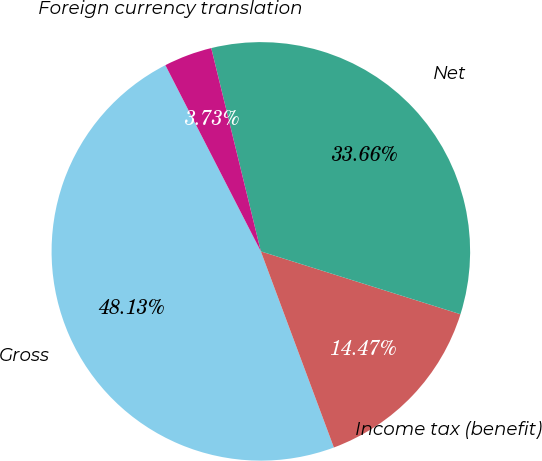Convert chart to OTSL. <chart><loc_0><loc_0><loc_500><loc_500><pie_chart><fcel>Gross<fcel>Income tax (benefit)<fcel>Net<fcel>Foreign currency translation<nl><fcel>48.13%<fcel>14.47%<fcel>33.66%<fcel>3.73%<nl></chart> 